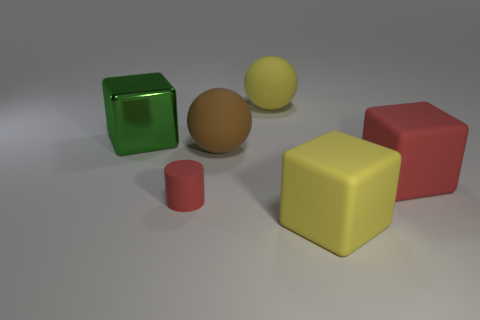There is a big yellow object that is the same shape as the big red matte object; what is it made of?
Offer a terse response. Rubber. How many metallic things are the same color as the cylinder?
Offer a terse response. 0. There is a cylinder that is made of the same material as the large yellow sphere; what is its size?
Make the answer very short. Small. What number of yellow things are tiny rubber things or large matte things?
Offer a terse response. 2. There is a yellow matte object that is on the right side of the big yellow ball; how many green metallic blocks are on the right side of it?
Ensure brevity in your answer.  0. Are there more big green things right of the yellow rubber sphere than red cylinders that are to the left of the small thing?
Ensure brevity in your answer.  No. What is the material of the large brown ball?
Give a very brief answer. Rubber. Is there a red block that has the same size as the green thing?
Provide a succinct answer. Yes. What material is the red object that is the same size as the yellow rubber block?
Provide a short and direct response. Rubber. What number of rubber cylinders are there?
Your answer should be compact. 1. 